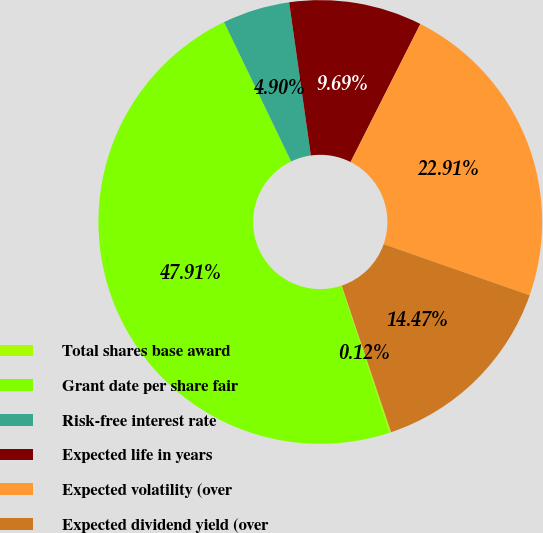<chart> <loc_0><loc_0><loc_500><loc_500><pie_chart><fcel>Total shares base award<fcel>Grant date per share fair<fcel>Risk-free interest rate<fcel>Expected life in years<fcel>Expected volatility (over<fcel>Expected dividend yield (over<nl><fcel>0.12%<fcel>47.91%<fcel>4.9%<fcel>9.69%<fcel>22.91%<fcel>14.47%<nl></chart> 